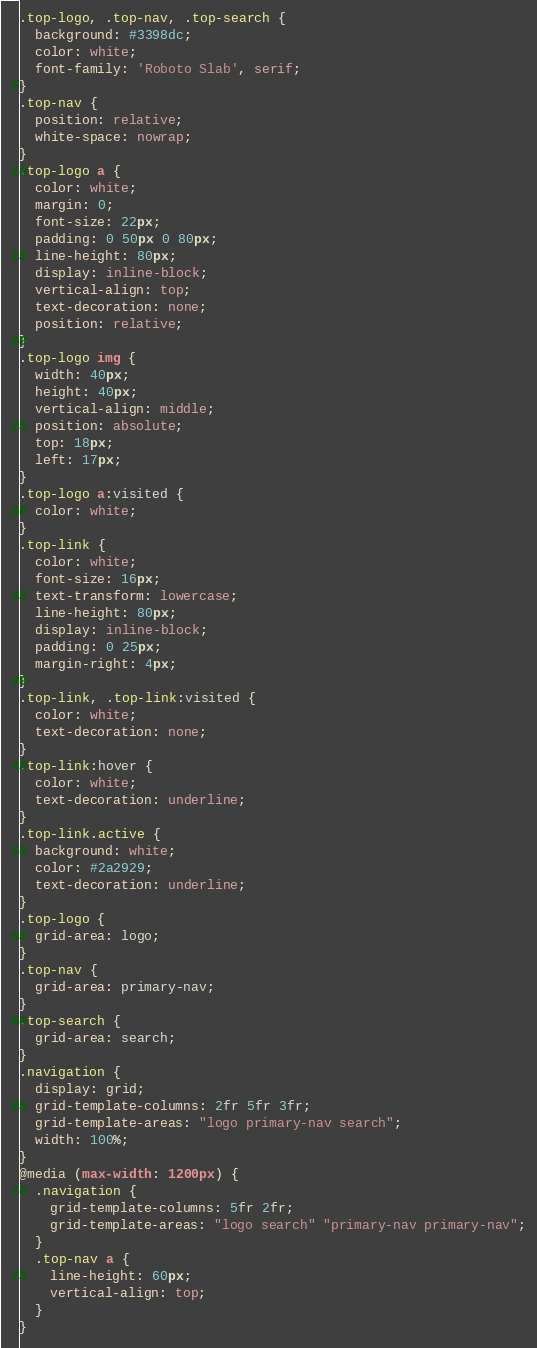<code> <loc_0><loc_0><loc_500><loc_500><_CSS_>.top-logo, .top-nav, .top-search {
  background: #3398dc;
  color: white;
  font-family: 'Roboto Slab', serif;
}
.top-nav {
  position: relative;
  white-space: nowrap;
}
.top-logo a {
  color: white;
  margin: 0;
  font-size: 22px;
  padding: 0 50px 0 80px;
  line-height: 80px;
  display: inline-block;
  vertical-align: top;
  text-decoration: none;
  position: relative;
}
.top-logo img {
  width: 40px;
  height: 40px;
  vertical-align: middle;
  position: absolute;
  top: 18px;
  left: 17px;
}
.top-logo a:visited {
  color: white;
}
.top-link {
  color: white;
  font-size: 16px;
  text-transform: lowercase;
  line-height: 80px;
  display: inline-block;
  padding: 0 25px;
  margin-right: 4px;
}
.top-link, .top-link:visited {
  color: white;
  text-decoration: none;
}
.top-link:hover {
  color: white;
  text-decoration: underline;
}
.top-link.active {
  background: white;
  color: #2a2929;
  text-decoration: underline;
}
.top-logo {
  grid-area: logo;
}
.top-nav {
  grid-area: primary-nav;
}
.top-search {
  grid-area: search;
}
.navigation {
  display: grid;
  grid-template-columns: 2fr 5fr 3fr;
  grid-template-areas: "logo primary-nav search";
  width: 100%;
}
@media (max-width: 1200px) {
  .navigation {
    grid-template-columns: 5fr 2fr;
    grid-template-areas: "logo search" "primary-nav primary-nav";
  }
  .top-nav a {
    line-height: 60px;
    vertical-align: top;
  }
}

</code> 